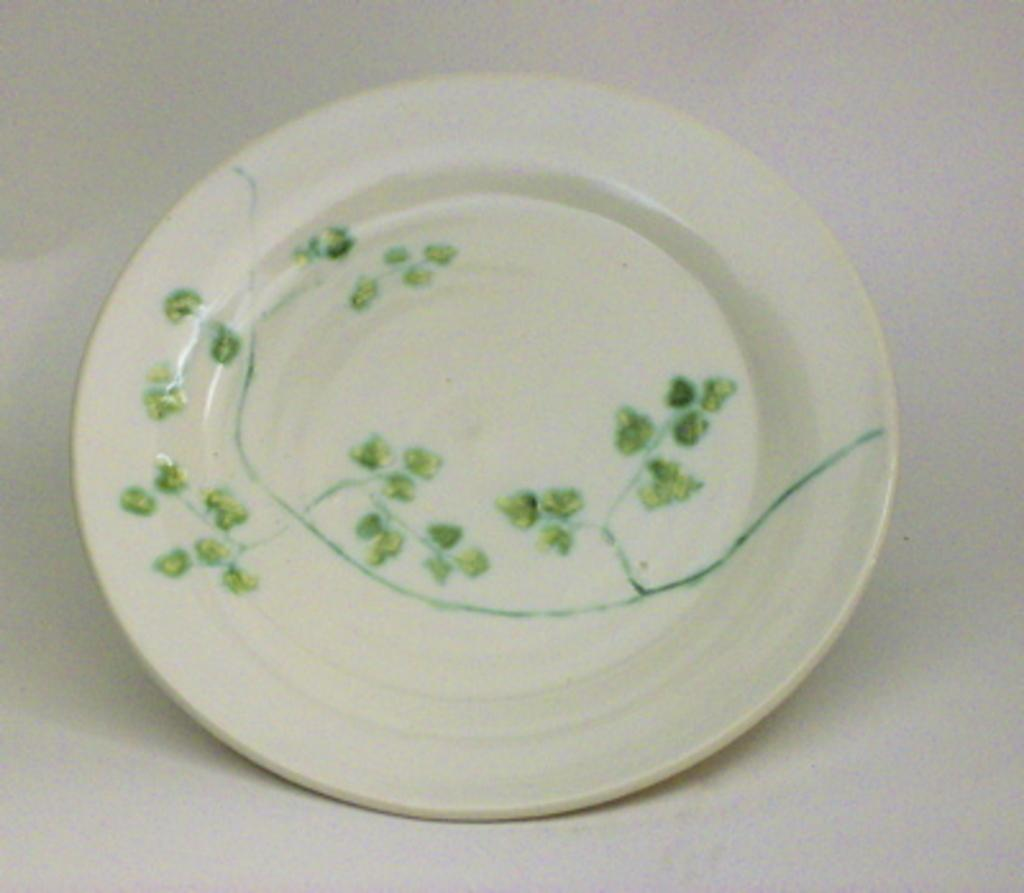What is located in the center of the image? There is a plate in the center of the image. What color is the background of the image? The background of the image is white. What type of support can be seen in the image? There is no visible support in the image; it only features a plate and a white background. 